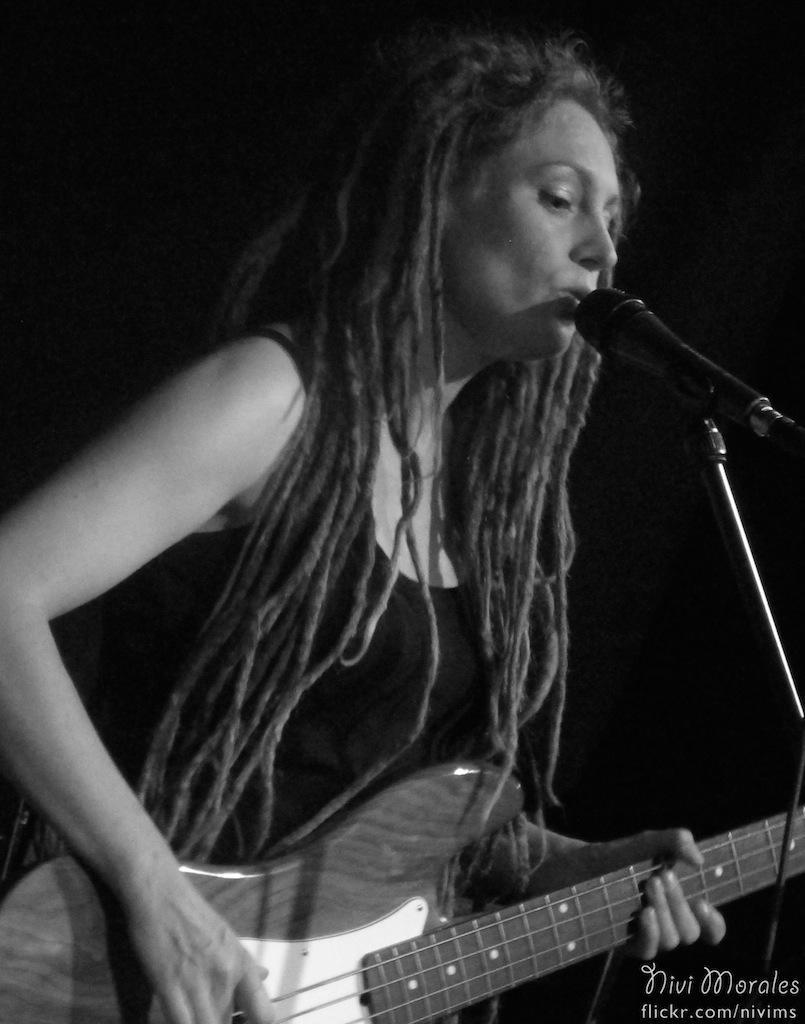In one or two sentences, can you explain what this image depicts? In this image there is a lady standing and holding a guitar in her hand. There is a mic before her. 